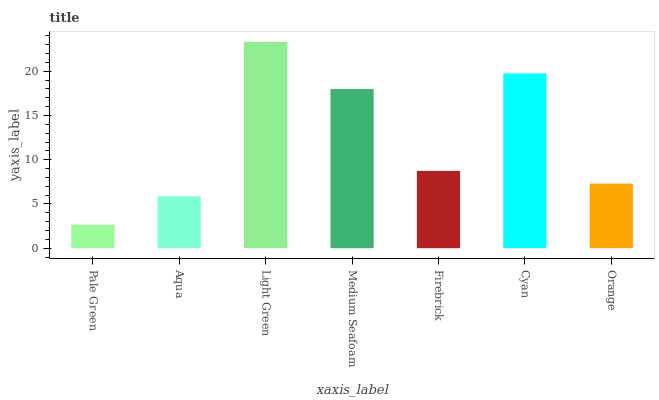Is Pale Green the minimum?
Answer yes or no. Yes. Is Light Green the maximum?
Answer yes or no. Yes. Is Aqua the minimum?
Answer yes or no. No. Is Aqua the maximum?
Answer yes or no. No. Is Aqua greater than Pale Green?
Answer yes or no. Yes. Is Pale Green less than Aqua?
Answer yes or no. Yes. Is Pale Green greater than Aqua?
Answer yes or no. No. Is Aqua less than Pale Green?
Answer yes or no. No. Is Firebrick the high median?
Answer yes or no. Yes. Is Firebrick the low median?
Answer yes or no. Yes. Is Pale Green the high median?
Answer yes or no. No. Is Medium Seafoam the low median?
Answer yes or no. No. 